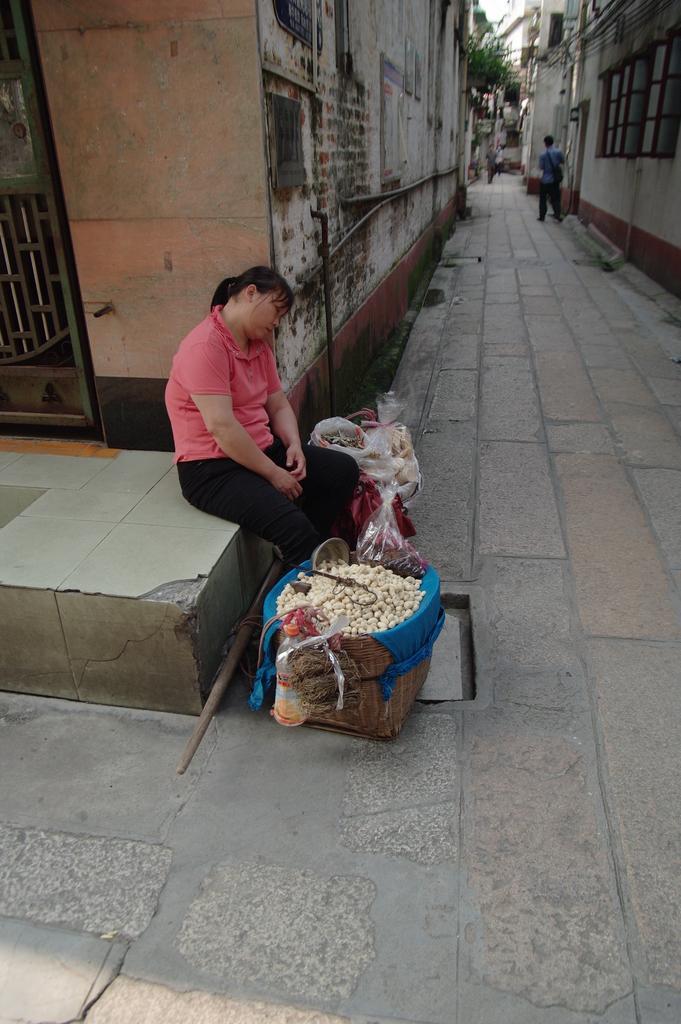How would you summarize this image in a sentence or two? In this image we can see a person sitting on a surface, in front of her there is a basket with some food items in it, there are some covers and bags around her, there is a stick, we can see a person standing, there are some buildings, and we can see a tree. 